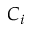Convert formula to latex. <formula><loc_0><loc_0><loc_500><loc_500>C _ { i }</formula> 